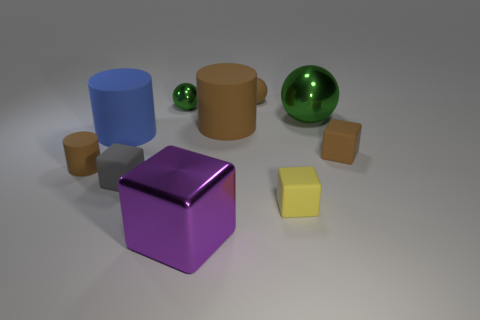The large shiny object that is on the right side of the large cube is what color? green 